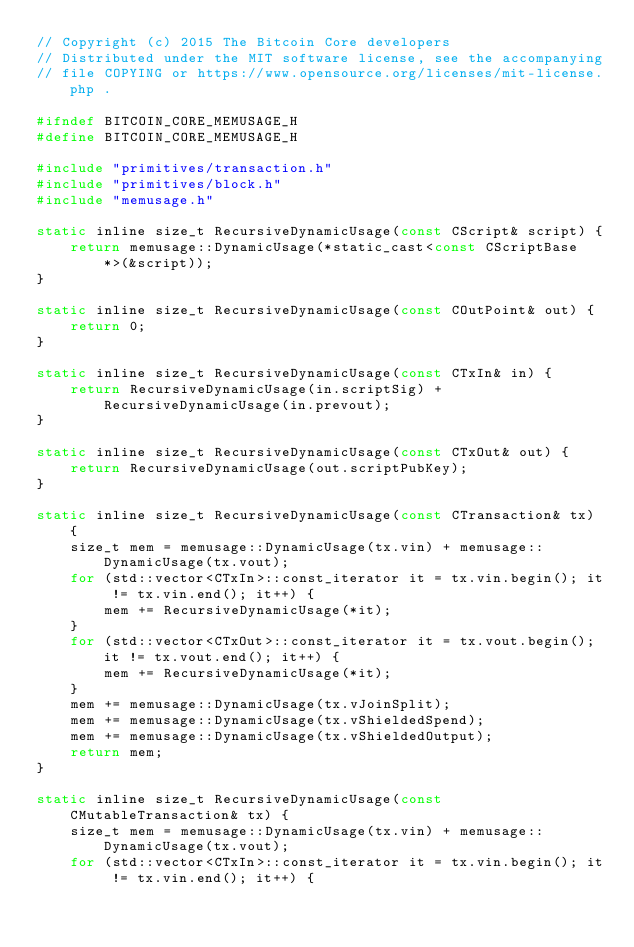Convert code to text. <code><loc_0><loc_0><loc_500><loc_500><_C_>// Copyright (c) 2015 The Bitcoin Core developers
// Distributed under the MIT software license, see the accompanying
// file COPYING or https://www.opensource.org/licenses/mit-license.php .

#ifndef BITCOIN_CORE_MEMUSAGE_H
#define BITCOIN_CORE_MEMUSAGE_H

#include "primitives/transaction.h"
#include "primitives/block.h"
#include "memusage.h"

static inline size_t RecursiveDynamicUsage(const CScript& script) {
    return memusage::DynamicUsage(*static_cast<const CScriptBase*>(&script));
}

static inline size_t RecursiveDynamicUsage(const COutPoint& out) {
    return 0;
}

static inline size_t RecursiveDynamicUsage(const CTxIn& in) {
    return RecursiveDynamicUsage(in.scriptSig) + RecursiveDynamicUsage(in.prevout);
}

static inline size_t RecursiveDynamicUsage(const CTxOut& out) {
    return RecursiveDynamicUsage(out.scriptPubKey);
}

static inline size_t RecursiveDynamicUsage(const CTransaction& tx) {
    size_t mem = memusage::DynamicUsage(tx.vin) + memusage::DynamicUsage(tx.vout);
    for (std::vector<CTxIn>::const_iterator it = tx.vin.begin(); it != tx.vin.end(); it++) {
        mem += RecursiveDynamicUsage(*it);
    }
    for (std::vector<CTxOut>::const_iterator it = tx.vout.begin(); it != tx.vout.end(); it++) {
        mem += RecursiveDynamicUsage(*it);
    }
    mem += memusage::DynamicUsage(tx.vJoinSplit);
    mem += memusage::DynamicUsage(tx.vShieldedSpend);
    mem += memusage::DynamicUsage(tx.vShieldedOutput);
    return mem;
}

static inline size_t RecursiveDynamicUsage(const CMutableTransaction& tx) {
    size_t mem = memusage::DynamicUsage(tx.vin) + memusage::DynamicUsage(tx.vout);
    for (std::vector<CTxIn>::const_iterator it = tx.vin.begin(); it != tx.vin.end(); it++) {</code> 